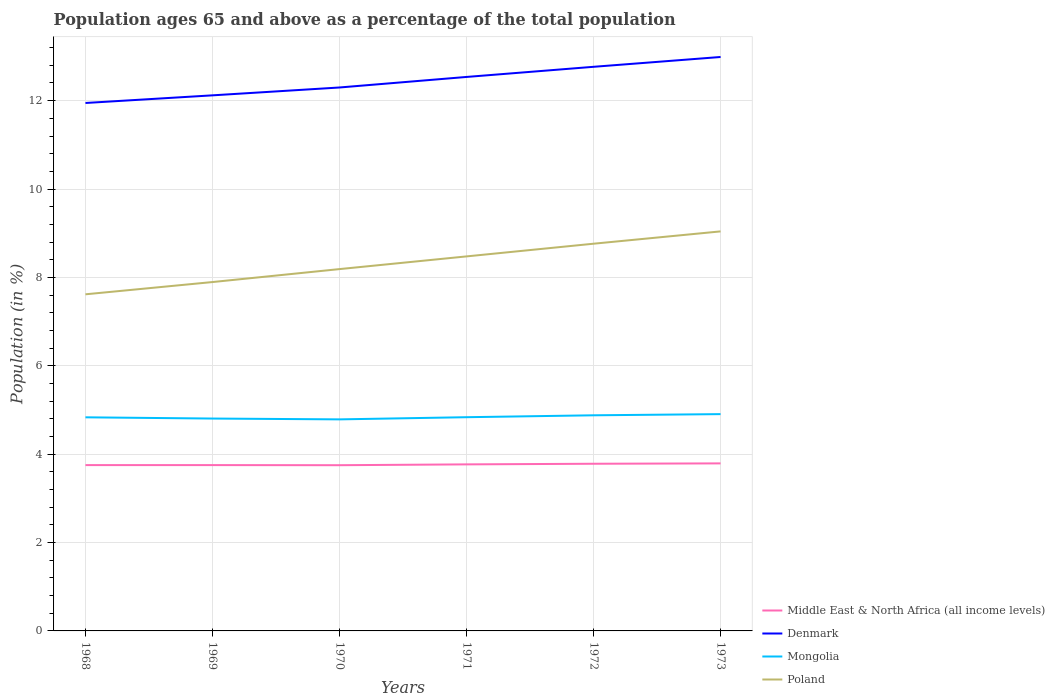How many different coloured lines are there?
Your answer should be very brief. 4. Does the line corresponding to Mongolia intersect with the line corresponding to Middle East & North Africa (all income levels)?
Offer a terse response. No. Across all years, what is the maximum percentage of the population ages 65 and above in Poland?
Your response must be concise. 7.62. In which year was the percentage of the population ages 65 and above in Denmark maximum?
Provide a succinct answer. 1968. What is the total percentage of the population ages 65 and above in Denmark in the graph?
Give a very brief answer. -0.17. What is the difference between the highest and the second highest percentage of the population ages 65 and above in Middle East & North Africa (all income levels)?
Your answer should be compact. 0.04. What is the difference between two consecutive major ticks on the Y-axis?
Ensure brevity in your answer.  2. Are the values on the major ticks of Y-axis written in scientific E-notation?
Provide a succinct answer. No. Does the graph contain any zero values?
Your answer should be very brief. No. How are the legend labels stacked?
Offer a terse response. Vertical. What is the title of the graph?
Your answer should be very brief. Population ages 65 and above as a percentage of the total population. What is the label or title of the Y-axis?
Give a very brief answer. Population (in %). What is the Population (in %) of Middle East & North Africa (all income levels) in 1968?
Your answer should be compact. 3.75. What is the Population (in %) in Denmark in 1968?
Provide a short and direct response. 11.95. What is the Population (in %) of Mongolia in 1968?
Make the answer very short. 4.83. What is the Population (in %) in Poland in 1968?
Keep it short and to the point. 7.62. What is the Population (in %) of Middle East & North Africa (all income levels) in 1969?
Give a very brief answer. 3.75. What is the Population (in %) of Denmark in 1969?
Keep it short and to the point. 12.12. What is the Population (in %) in Mongolia in 1969?
Provide a succinct answer. 4.81. What is the Population (in %) of Poland in 1969?
Ensure brevity in your answer.  7.9. What is the Population (in %) in Middle East & North Africa (all income levels) in 1970?
Make the answer very short. 3.75. What is the Population (in %) of Denmark in 1970?
Provide a succinct answer. 12.3. What is the Population (in %) of Mongolia in 1970?
Keep it short and to the point. 4.79. What is the Population (in %) of Poland in 1970?
Offer a terse response. 8.19. What is the Population (in %) of Middle East & North Africa (all income levels) in 1971?
Your answer should be very brief. 3.77. What is the Population (in %) in Denmark in 1971?
Your answer should be compact. 12.54. What is the Population (in %) in Mongolia in 1971?
Offer a very short reply. 4.84. What is the Population (in %) of Poland in 1971?
Your answer should be very brief. 8.48. What is the Population (in %) of Middle East & North Africa (all income levels) in 1972?
Make the answer very short. 3.78. What is the Population (in %) of Denmark in 1972?
Provide a short and direct response. 12.77. What is the Population (in %) of Mongolia in 1972?
Make the answer very short. 4.88. What is the Population (in %) in Poland in 1972?
Provide a succinct answer. 8.76. What is the Population (in %) of Middle East & North Africa (all income levels) in 1973?
Give a very brief answer. 3.79. What is the Population (in %) in Denmark in 1973?
Your answer should be very brief. 12.99. What is the Population (in %) in Mongolia in 1973?
Ensure brevity in your answer.  4.91. What is the Population (in %) in Poland in 1973?
Provide a succinct answer. 9.04. Across all years, what is the maximum Population (in %) of Middle East & North Africa (all income levels)?
Ensure brevity in your answer.  3.79. Across all years, what is the maximum Population (in %) in Denmark?
Keep it short and to the point. 12.99. Across all years, what is the maximum Population (in %) of Mongolia?
Provide a short and direct response. 4.91. Across all years, what is the maximum Population (in %) in Poland?
Make the answer very short. 9.04. Across all years, what is the minimum Population (in %) in Middle East & North Africa (all income levels)?
Ensure brevity in your answer.  3.75. Across all years, what is the minimum Population (in %) of Denmark?
Your answer should be very brief. 11.95. Across all years, what is the minimum Population (in %) in Mongolia?
Offer a terse response. 4.79. Across all years, what is the minimum Population (in %) of Poland?
Give a very brief answer. 7.62. What is the total Population (in %) of Middle East & North Africa (all income levels) in the graph?
Ensure brevity in your answer.  22.6. What is the total Population (in %) in Denmark in the graph?
Your answer should be compact. 74.66. What is the total Population (in %) in Mongolia in the graph?
Your answer should be compact. 29.05. What is the total Population (in %) of Poland in the graph?
Keep it short and to the point. 49.98. What is the difference between the Population (in %) of Middle East & North Africa (all income levels) in 1968 and that in 1969?
Your answer should be compact. 0. What is the difference between the Population (in %) of Denmark in 1968 and that in 1969?
Your answer should be compact. -0.17. What is the difference between the Population (in %) in Mongolia in 1968 and that in 1969?
Ensure brevity in your answer.  0.03. What is the difference between the Population (in %) of Poland in 1968 and that in 1969?
Offer a terse response. -0.28. What is the difference between the Population (in %) of Middle East & North Africa (all income levels) in 1968 and that in 1970?
Give a very brief answer. 0. What is the difference between the Population (in %) of Denmark in 1968 and that in 1970?
Keep it short and to the point. -0.35. What is the difference between the Population (in %) of Mongolia in 1968 and that in 1970?
Offer a very short reply. 0.05. What is the difference between the Population (in %) in Poland in 1968 and that in 1970?
Offer a terse response. -0.57. What is the difference between the Population (in %) in Middle East & North Africa (all income levels) in 1968 and that in 1971?
Your response must be concise. -0.02. What is the difference between the Population (in %) of Denmark in 1968 and that in 1971?
Ensure brevity in your answer.  -0.59. What is the difference between the Population (in %) of Mongolia in 1968 and that in 1971?
Make the answer very short. -0. What is the difference between the Population (in %) in Poland in 1968 and that in 1971?
Offer a very short reply. -0.86. What is the difference between the Population (in %) of Middle East & North Africa (all income levels) in 1968 and that in 1972?
Ensure brevity in your answer.  -0.03. What is the difference between the Population (in %) in Denmark in 1968 and that in 1972?
Offer a very short reply. -0.82. What is the difference between the Population (in %) of Mongolia in 1968 and that in 1972?
Ensure brevity in your answer.  -0.05. What is the difference between the Population (in %) of Poland in 1968 and that in 1972?
Offer a terse response. -1.14. What is the difference between the Population (in %) in Middle East & North Africa (all income levels) in 1968 and that in 1973?
Provide a succinct answer. -0.04. What is the difference between the Population (in %) in Denmark in 1968 and that in 1973?
Make the answer very short. -1.04. What is the difference between the Population (in %) in Mongolia in 1968 and that in 1973?
Your response must be concise. -0.07. What is the difference between the Population (in %) of Poland in 1968 and that in 1973?
Your answer should be very brief. -1.42. What is the difference between the Population (in %) in Middle East & North Africa (all income levels) in 1969 and that in 1970?
Ensure brevity in your answer.  0. What is the difference between the Population (in %) in Denmark in 1969 and that in 1970?
Provide a succinct answer. -0.18. What is the difference between the Population (in %) of Mongolia in 1969 and that in 1970?
Make the answer very short. 0.02. What is the difference between the Population (in %) of Poland in 1969 and that in 1970?
Make the answer very short. -0.29. What is the difference between the Population (in %) of Middle East & North Africa (all income levels) in 1969 and that in 1971?
Your answer should be compact. -0.02. What is the difference between the Population (in %) of Denmark in 1969 and that in 1971?
Your answer should be compact. -0.42. What is the difference between the Population (in %) in Mongolia in 1969 and that in 1971?
Your answer should be very brief. -0.03. What is the difference between the Population (in %) in Poland in 1969 and that in 1971?
Your response must be concise. -0.58. What is the difference between the Population (in %) in Middle East & North Africa (all income levels) in 1969 and that in 1972?
Your answer should be compact. -0.03. What is the difference between the Population (in %) of Denmark in 1969 and that in 1972?
Provide a short and direct response. -0.65. What is the difference between the Population (in %) in Mongolia in 1969 and that in 1972?
Make the answer very short. -0.07. What is the difference between the Population (in %) of Poland in 1969 and that in 1972?
Provide a short and direct response. -0.87. What is the difference between the Population (in %) in Middle East & North Africa (all income levels) in 1969 and that in 1973?
Provide a succinct answer. -0.04. What is the difference between the Population (in %) in Denmark in 1969 and that in 1973?
Make the answer very short. -0.87. What is the difference between the Population (in %) in Mongolia in 1969 and that in 1973?
Provide a succinct answer. -0.1. What is the difference between the Population (in %) in Poland in 1969 and that in 1973?
Your response must be concise. -1.15. What is the difference between the Population (in %) of Middle East & North Africa (all income levels) in 1970 and that in 1971?
Ensure brevity in your answer.  -0.02. What is the difference between the Population (in %) in Denmark in 1970 and that in 1971?
Provide a succinct answer. -0.24. What is the difference between the Population (in %) in Mongolia in 1970 and that in 1971?
Offer a terse response. -0.05. What is the difference between the Population (in %) of Poland in 1970 and that in 1971?
Ensure brevity in your answer.  -0.29. What is the difference between the Population (in %) of Middle East & North Africa (all income levels) in 1970 and that in 1972?
Your answer should be compact. -0.03. What is the difference between the Population (in %) of Denmark in 1970 and that in 1972?
Provide a succinct answer. -0.47. What is the difference between the Population (in %) in Mongolia in 1970 and that in 1972?
Make the answer very short. -0.09. What is the difference between the Population (in %) of Poland in 1970 and that in 1972?
Provide a short and direct response. -0.57. What is the difference between the Population (in %) of Middle East & North Africa (all income levels) in 1970 and that in 1973?
Provide a succinct answer. -0.04. What is the difference between the Population (in %) of Denmark in 1970 and that in 1973?
Your response must be concise. -0.69. What is the difference between the Population (in %) of Mongolia in 1970 and that in 1973?
Provide a short and direct response. -0.12. What is the difference between the Population (in %) in Poland in 1970 and that in 1973?
Offer a terse response. -0.85. What is the difference between the Population (in %) of Middle East & North Africa (all income levels) in 1971 and that in 1972?
Provide a succinct answer. -0.01. What is the difference between the Population (in %) of Denmark in 1971 and that in 1972?
Your answer should be compact. -0.23. What is the difference between the Population (in %) in Mongolia in 1971 and that in 1972?
Provide a succinct answer. -0.04. What is the difference between the Population (in %) of Poland in 1971 and that in 1972?
Offer a very short reply. -0.29. What is the difference between the Population (in %) in Middle East & North Africa (all income levels) in 1971 and that in 1973?
Your answer should be compact. -0.02. What is the difference between the Population (in %) of Denmark in 1971 and that in 1973?
Your answer should be compact. -0.45. What is the difference between the Population (in %) of Mongolia in 1971 and that in 1973?
Give a very brief answer. -0.07. What is the difference between the Population (in %) in Poland in 1971 and that in 1973?
Make the answer very short. -0.57. What is the difference between the Population (in %) of Middle East & North Africa (all income levels) in 1972 and that in 1973?
Provide a short and direct response. -0.01. What is the difference between the Population (in %) in Denmark in 1972 and that in 1973?
Give a very brief answer. -0.22. What is the difference between the Population (in %) of Mongolia in 1972 and that in 1973?
Ensure brevity in your answer.  -0.03. What is the difference between the Population (in %) of Poland in 1972 and that in 1973?
Give a very brief answer. -0.28. What is the difference between the Population (in %) in Middle East & North Africa (all income levels) in 1968 and the Population (in %) in Denmark in 1969?
Your response must be concise. -8.37. What is the difference between the Population (in %) of Middle East & North Africa (all income levels) in 1968 and the Population (in %) of Mongolia in 1969?
Provide a succinct answer. -1.05. What is the difference between the Population (in %) in Middle East & North Africa (all income levels) in 1968 and the Population (in %) in Poland in 1969?
Your answer should be very brief. -4.14. What is the difference between the Population (in %) of Denmark in 1968 and the Population (in %) of Mongolia in 1969?
Offer a very short reply. 7.14. What is the difference between the Population (in %) in Denmark in 1968 and the Population (in %) in Poland in 1969?
Offer a terse response. 4.05. What is the difference between the Population (in %) in Mongolia in 1968 and the Population (in %) in Poland in 1969?
Provide a short and direct response. -3.06. What is the difference between the Population (in %) in Middle East & North Africa (all income levels) in 1968 and the Population (in %) in Denmark in 1970?
Provide a short and direct response. -8.55. What is the difference between the Population (in %) in Middle East & North Africa (all income levels) in 1968 and the Population (in %) in Mongolia in 1970?
Your response must be concise. -1.03. What is the difference between the Population (in %) of Middle East & North Africa (all income levels) in 1968 and the Population (in %) of Poland in 1970?
Ensure brevity in your answer.  -4.44. What is the difference between the Population (in %) of Denmark in 1968 and the Population (in %) of Mongolia in 1970?
Provide a short and direct response. 7.16. What is the difference between the Population (in %) in Denmark in 1968 and the Population (in %) in Poland in 1970?
Provide a succinct answer. 3.76. What is the difference between the Population (in %) of Mongolia in 1968 and the Population (in %) of Poland in 1970?
Offer a terse response. -3.35. What is the difference between the Population (in %) of Middle East & North Africa (all income levels) in 1968 and the Population (in %) of Denmark in 1971?
Give a very brief answer. -8.78. What is the difference between the Population (in %) in Middle East & North Africa (all income levels) in 1968 and the Population (in %) in Mongolia in 1971?
Your answer should be very brief. -1.08. What is the difference between the Population (in %) of Middle East & North Africa (all income levels) in 1968 and the Population (in %) of Poland in 1971?
Provide a succinct answer. -4.72. What is the difference between the Population (in %) of Denmark in 1968 and the Population (in %) of Mongolia in 1971?
Your answer should be compact. 7.11. What is the difference between the Population (in %) in Denmark in 1968 and the Population (in %) in Poland in 1971?
Ensure brevity in your answer.  3.47. What is the difference between the Population (in %) in Mongolia in 1968 and the Population (in %) in Poland in 1971?
Keep it short and to the point. -3.64. What is the difference between the Population (in %) of Middle East & North Africa (all income levels) in 1968 and the Population (in %) of Denmark in 1972?
Provide a succinct answer. -9.01. What is the difference between the Population (in %) in Middle East & North Africa (all income levels) in 1968 and the Population (in %) in Mongolia in 1972?
Ensure brevity in your answer.  -1.13. What is the difference between the Population (in %) in Middle East & North Africa (all income levels) in 1968 and the Population (in %) in Poland in 1972?
Keep it short and to the point. -5.01. What is the difference between the Population (in %) of Denmark in 1968 and the Population (in %) of Mongolia in 1972?
Provide a short and direct response. 7.07. What is the difference between the Population (in %) of Denmark in 1968 and the Population (in %) of Poland in 1972?
Your answer should be compact. 3.18. What is the difference between the Population (in %) of Mongolia in 1968 and the Population (in %) of Poland in 1972?
Your answer should be compact. -3.93. What is the difference between the Population (in %) of Middle East & North Africa (all income levels) in 1968 and the Population (in %) of Denmark in 1973?
Offer a very short reply. -9.24. What is the difference between the Population (in %) of Middle East & North Africa (all income levels) in 1968 and the Population (in %) of Mongolia in 1973?
Your response must be concise. -1.15. What is the difference between the Population (in %) of Middle East & North Africa (all income levels) in 1968 and the Population (in %) of Poland in 1973?
Keep it short and to the point. -5.29. What is the difference between the Population (in %) of Denmark in 1968 and the Population (in %) of Mongolia in 1973?
Your answer should be compact. 7.04. What is the difference between the Population (in %) of Denmark in 1968 and the Population (in %) of Poland in 1973?
Your answer should be compact. 2.91. What is the difference between the Population (in %) of Mongolia in 1968 and the Population (in %) of Poland in 1973?
Offer a terse response. -4.21. What is the difference between the Population (in %) in Middle East & North Africa (all income levels) in 1969 and the Population (in %) in Denmark in 1970?
Offer a very short reply. -8.55. What is the difference between the Population (in %) in Middle East & North Africa (all income levels) in 1969 and the Population (in %) in Mongolia in 1970?
Provide a short and direct response. -1.03. What is the difference between the Population (in %) in Middle East & North Africa (all income levels) in 1969 and the Population (in %) in Poland in 1970?
Offer a very short reply. -4.44. What is the difference between the Population (in %) in Denmark in 1969 and the Population (in %) in Mongolia in 1970?
Your answer should be compact. 7.33. What is the difference between the Population (in %) in Denmark in 1969 and the Population (in %) in Poland in 1970?
Give a very brief answer. 3.93. What is the difference between the Population (in %) of Mongolia in 1969 and the Population (in %) of Poland in 1970?
Keep it short and to the point. -3.38. What is the difference between the Population (in %) of Middle East & North Africa (all income levels) in 1969 and the Population (in %) of Denmark in 1971?
Provide a succinct answer. -8.78. What is the difference between the Population (in %) in Middle East & North Africa (all income levels) in 1969 and the Population (in %) in Mongolia in 1971?
Offer a terse response. -1.08. What is the difference between the Population (in %) in Middle East & North Africa (all income levels) in 1969 and the Population (in %) in Poland in 1971?
Make the answer very short. -4.72. What is the difference between the Population (in %) in Denmark in 1969 and the Population (in %) in Mongolia in 1971?
Keep it short and to the point. 7.28. What is the difference between the Population (in %) of Denmark in 1969 and the Population (in %) of Poland in 1971?
Your answer should be compact. 3.64. What is the difference between the Population (in %) of Mongolia in 1969 and the Population (in %) of Poland in 1971?
Give a very brief answer. -3.67. What is the difference between the Population (in %) of Middle East & North Africa (all income levels) in 1969 and the Population (in %) of Denmark in 1972?
Give a very brief answer. -9.01. What is the difference between the Population (in %) of Middle East & North Africa (all income levels) in 1969 and the Population (in %) of Mongolia in 1972?
Offer a terse response. -1.13. What is the difference between the Population (in %) of Middle East & North Africa (all income levels) in 1969 and the Population (in %) of Poland in 1972?
Keep it short and to the point. -5.01. What is the difference between the Population (in %) of Denmark in 1969 and the Population (in %) of Mongolia in 1972?
Keep it short and to the point. 7.24. What is the difference between the Population (in %) of Denmark in 1969 and the Population (in %) of Poland in 1972?
Provide a short and direct response. 3.36. What is the difference between the Population (in %) in Mongolia in 1969 and the Population (in %) in Poland in 1972?
Your response must be concise. -3.96. What is the difference between the Population (in %) in Middle East & North Africa (all income levels) in 1969 and the Population (in %) in Denmark in 1973?
Provide a short and direct response. -9.24. What is the difference between the Population (in %) of Middle East & North Africa (all income levels) in 1969 and the Population (in %) of Mongolia in 1973?
Your response must be concise. -1.15. What is the difference between the Population (in %) in Middle East & North Africa (all income levels) in 1969 and the Population (in %) in Poland in 1973?
Provide a short and direct response. -5.29. What is the difference between the Population (in %) of Denmark in 1969 and the Population (in %) of Mongolia in 1973?
Your answer should be very brief. 7.21. What is the difference between the Population (in %) in Denmark in 1969 and the Population (in %) in Poland in 1973?
Give a very brief answer. 3.08. What is the difference between the Population (in %) in Mongolia in 1969 and the Population (in %) in Poland in 1973?
Your answer should be very brief. -4.24. What is the difference between the Population (in %) in Middle East & North Africa (all income levels) in 1970 and the Population (in %) in Denmark in 1971?
Make the answer very short. -8.79. What is the difference between the Population (in %) in Middle East & North Africa (all income levels) in 1970 and the Population (in %) in Mongolia in 1971?
Your answer should be very brief. -1.09. What is the difference between the Population (in %) of Middle East & North Africa (all income levels) in 1970 and the Population (in %) of Poland in 1971?
Keep it short and to the point. -4.73. What is the difference between the Population (in %) of Denmark in 1970 and the Population (in %) of Mongolia in 1971?
Provide a short and direct response. 7.46. What is the difference between the Population (in %) of Denmark in 1970 and the Population (in %) of Poland in 1971?
Your answer should be compact. 3.82. What is the difference between the Population (in %) of Mongolia in 1970 and the Population (in %) of Poland in 1971?
Your answer should be very brief. -3.69. What is the difference between the Population (in %) in Middle East & North Africa (all income levels) in 1970 and the Population (in %) in Denmark in 1972?
Your response must be concise. -9.02. What is the difference between the Population (in %) in Middle East & North Africa (all income levels) in 1970 and the Population (in %) in Mongolia in 1972?
Keep it short and to the point. -1.13. What is the difference between the Population (in %) of Middle East & North Africa (all income levels) in 1970 and the Population (in %) of Poland in 1972?
Keep it short and to the point. -5.01. What is the difference between the Population (in %) of Denmark in 1970 and the Population (in %) of Mongolia in 1972?
Your answer should be compact. 7.42. What is the difference between the Population (in %) of Denmark in 1970 and the Population (in %) of Poland in 1972?
Your answer should be very brief. 3.54. What is the difference between the Population (in %) in Mongolia in 1970 and the Population (in %) in Poland in 1972?
Give a very brief answer. -3.98. What is the difference between the Population (in %) in Middle East & North Africa (all income levels) in 1970 and the Population (in %) in Denmark in 1973?
Make the answer very short. -9.24. What is the difference between the Population (in %) of Middle East & North Africa (all income levels) in 1970 and the Population (in %) of Mongolia in 1973?
Offer a very short reply. -1.16. What is the difference between the Population (in %) of Middle East & North Africa (all income levels) in 1970 and the Population (in %) of Poland in 1973?
Offer a very short reply. -5.29. What is the difference between the Population (in %) of Denmark in 1970 and the Population (in %) of Mongolia in 1973?
Provide a succinct answer. 7.39. What is the difference between the Population (in %) of Denmark in 1970 and the Population (in %) of Poland in 1973?
Your answer should be compact. 3.26. What is the difference between the Population (in %) in Mongolia in 1970 and the Population (in %) in Poland in 1973?
Keep it short and to the point. -4.25. What is the difference between the Population (in %) in Middle East & North Africa (all income levels) in 1971 and the Population (in %) in Denmark in 1972?
Give a very brief answer. -9. What is the difference between the Population (in %) of Middle East & North Africa (all income levels) in 1971 and the Population (in %) of Mongolia in 1972?
Give a very brief answer. -1.11. What is the difference between the Population (in %) of Middle East & North Africa (all income levels) in 1971 and the Population (in %) of Poland in 1972?
Provide a succinct answer. -4.99. What is the difference between the Population (in %) in Denmark in 1971 and the Population (in %) in Mongolia in 1972?
Provide a short and direct response. 7.66. What is the difference between the Population (in %) in Denmark in 1971 and the Population (in %) in Poland in 1972?
Your answer should be compact. 3.77. What is the difference between the Population (in %) in Mongolia in 1971 and the Population (in %) in Poland in 1972?
Ensure brevity in your answer.  -3.93. What is the difference between the Population (in %) in Middle East & North Africa (all income levels) in 1971 and the Population (in %) in Denmark in 1973?
Provide a short and direct response. -9.22. What is the difference between the Population (in %) of Middle East & North Africa (all income levels) in 1971 and the Population (in %) of Mongolia in 1973?
Keep it short and to the point. -1.14. What is the difference between the Population (in %) of Middle East & North Africa (all income levels) in 1971 and the Population (in %) of Poland in 1973?
Offer a terse response. -5.27. What is the difference between the Population (in %) of Denmark in 1971 and the Population (in %) of Mongolia in 1973?
Make the answer very short. 7.63. What is the difference between the Population (in %) in Denmark in 1971 and the Population (in %) in Poland in 1973?
Offer a very short reply. 3.5. What is the difference between the Population (in %) in Mongolia in 1971 and the Population (in %) in Poland in 1973?
Provide a succinct answer. -4.21. What is the difference between the Population (in %) of Middle East & North Africa (all income levels) in 1972 and the Population (in %) of Denmark in 1973?
Ensure brevity in your answer.  -9.21. What is the difference between the Population (in %) in Middle East & North Africa (all income levels) in 1972 and the Population (in %) in Mongolia in 1973?
Make the answer very short. -1.12. What is the difference between the Population (in %) of Middle East & North Africa (all income levels) in 1972 and the Population (in %) of Poland in 1973?
Offer a very short reply. -5.26. What is the difference between the Population (in %) of Denmark in 1972 and the Population (in %) of Mongolia in 1973?
Give a very brief answer. 7.86. What is the difference between the Population (in %) in Denmark in 1972 and the Population (in %) in Poland in 1973?
Offer a terse response. 3.72. What is the difference between the Population (in %) in Mongolia in 1972 and the Population (in %) in Poland in 1973?
Provide a short and direct response. -4.16. What is the average Population (in %) in Middle East & North Africa (all income levels) per year?
Your answer should be very brief. 3.77. What is the average Population (in %) of Denmark per year?
Provide a short and direct response. 12.44. What is the average Population (in %) of Mongolia per year?
Ensure brevity in your answer.  4.84. What is the average Population (in %) in Poland per year?
Your answer should be very brief. 8.33. In the year 1968, what is the difference between the Population (in %) of Middle East & North Africa (all income levels) and Population (in %) of Denmark?
Give a very brief answer. -8.19. In the year 1968, what is the difference between the Population (in %) of Middle East & North Africa (all income levels) and Population (in %) of Mongolia?
Provide a succinct answer. -1.08. In the year 1968, what is the difference between the Population (in %) of Middle East & North Africa (all income levels) and Population (in %) of Poland?
Provide a succinct answer. -3.86. In the year 1968, what is the difference between the Population (in %) of Denmark and Population (in %) of Mongolia?
Make the answer very short. 7.11. In the year 1968, what is the difference between the Population (in %) of Denmark and Population (in %) of Poland?
Provide a succinct answer. 4.33. In the year 1968, what is the difference between the Population (in %) in Mongolia and Population (in %) in Poland?
Your answer should be compact. -2.78. In the year 1969, what is the difference between the Population (in %) of Middle East & North Africa (all income levels) and Population (in %) of Denmark?
Offer a terse response. -8.37. In the year 1969, what is the difference between the Population (in %) of Middle East & North Africa (all income levels) and Population (in %) of Mongolia?
Offer a very short reply. -1.05. In the year 1969, what is the difference between the Population (in %) of Middle East & North Africa (all income levels) and Population (in %) of Poland?
Offer a very short reply. -4.14. In the year 1969, what is the difference between the Population (in %) of Denmark and Population (in %) of Mongolia?
Make the answer very short. 7.31. In the year 1969, what is the difference between the Population (in %) in Denmark and Population (in %) in Poland?
Your answer should be compact. 4.23. In the year 1969, what is the difference between the Population (in %) in Mongolia and Population (in %) in Poland?
Provide a short and direct response. -3.09. In the year 1970, what is the difference between the Population (in %) of Middle East & North Africa (all income levels) and Population (in %) of Denmark?
Your response must be concise. -8.55. In the year 1970, what is the difference between the Population (in %) of Middle East & North Africa (all income levels) and Population (in %) of Mongolia?
Ensure brevity in your answer.  -1.04. In the year 1970, what is the difference between the Population (in %) of Middle East & North Africa (all income levels) and Population (in %) of Poland?
Give a very brief answer. -4.44. In the year 1970, what is the difference between the Population (in %) in Denmark and Population (in %) in Mongolia?
Offer a terse response. 7.51. In the year 1970, what is the difference between the Population (in %) of Denmark and Population (in %) of Poland?
Make the answer very short. 4.11. In the year 1970, what is the difference between the Population (in %) in Mongolia and Population (in %) in Poland?
Provide a succinct answer. -3.4. In the year 1971, what is the difference between the Population (in %) of Middle East & North Africa (all income levels) and Population (in %) of Denmark?
Your response must be concise. -8.77. In the year 1971, what is the difference between the Population (in %) of Middle East & North Africa (all income levels) and Population (in %) of Mongolia?
Your answer should be very brief. -1.07. In the year 1971, what is the difference between the Population (in %) in Middle East & North Africa (all income levels) and Population (in %) in Poland?
Provide a short and direct response. -4.71. In the year 1971, what is the difference between the Population (in %) of Denmark and Population (in %) of Mongolia?
Your answer should be compact. 7.7. In the year 1971, what is the difference between the Population (in %) in Denmark and Population (in %) in Poland?
Your response must be concise. 4.06. In the year 1971, what is the difference between the Population (in %) of Mongolia and Population (in %) of Poland?
Give a very brief answer. -3.64. In the year 1972, what is the difference between the Population (in %) in Middle East & North Africa (all income levels) and Population (in %) in Denmark?
Your response must be concise. -8.98. In the year 1972, what is the difference between the Population (in %) in Middle East & North Africa (all income levels) and Population (in %) in Mongolia?
Provide a short and direct response. -1.1. In the year 1972, what is the difference between the Population (in %) in Middle East & North Africa (all income levels) and Population (in %) in Poland?
Your response must be concise. -4.98. In the year 1972, what is the difference between the Population (in %) in Denmark and Population (in %) in Mongolia?
Offer a very short reply. 7.89. In the year 1972, what is the difference between the Population (in %) of Denmark and Population (in %) of Poland?
Your answer should be compact. 4. In the year 1972, what is the difference between the Population (in %) of Mongolia and Population (in %) of Poland?
Offer a very short reply. -3.88. In the year 1973, what is the difference between the Population (in %) of Middle East & North Africa (all income levels) and Population (in %) of Denmark?
Provide a short and direct response. -9.2. In the year 1973, what is the difference between the Population (in %) in Middle East & North Africa (all income levels) and Population (in %) in Mongolia?
Ensure brevity in your answer.  -1.11. In the year 1973, what is the difference between the Population (in %) of Middle East & North Africa (all income levels) and Population (in %) of Poland?
Offer a very short reply. -5.25. In the year 1973, what is the difference between the Population (in %) of Denmark and Population (in %) of Mongolia?
Offer a very short reply. 8.08. In the year 1973, what is the difference between the Population (in %) in Denmark and Population (in %) in Poland?
Offer a terse response. 3.95. In the year 1973, what is the difference between the Population (in %) of Mongolia and Population (in %) of Poland?
Provide a succinct answer. -4.14. What is the ratio of the Population (in %) in Denmark in 1968 to that in 1969?
Give a very brief answer. 0.99. What is the ratio of the Population (in %) of Mongolia in 1968 to that in 1969?
Your answer should be very brief. 1.01. What is the ratio of the Population (in %) in Poland in 1968 to that in 1969?
Ensure brevity in your answer.  0.96. What is the ratio of the Population (in %) of Denmark in 1968 to that in 1970?
Make the answer very short. 0.97. What is the ratio of the Population (in %) in Mongolia in 1968 to that in 1970?
Provide a short and direct response. 1.01. What is the ratio of the Population (in %) in Poland in 1968 to that in 1970?
Your response must be concise. 0.93. What is the ratio of the Population (in %) in Denmark in 1968 to that in 1971?
Make the answer very short. 0.95. What is the ratio of the Population (in %) in Mongolia in 1968 to that in 1971?
Your response must be concise. 1. What is the ratio of the Population (in %) in Poland in 1968 to that in 1971?
Your answer should be very brief. 0.9. What is the ratio of the Population (in %) of Denmark in 1968 to that in 1972?
Offer a very short reply. 0.94. What is the ratio of the Population (in %) of Poland in 1968 to that in 1972?
Ensure brevity in your answer.  0.87. What is the ratio of the Population (in %) of Denmark in 1968 to that in 1973?
Make the answer very short. 0.92. What is the ratio of the Population (in %) in Poland in 1968 to that in 1973?
Give a very brief answer. 0.84. What is the ratio of the Population (in %) in Denmark in 1969 to that in 1970?
Offer a very short reply. 0.99. What is the ratio of the Population (in %) in Mongolia in 1969 to that in 1970?
Make the answer very short. 1. What is the ratio of the Population (in %) in Poland in 1969 to that in 1970?
Make the answer very short. 0.96. What is the ratio of the Population (in %) of Denmark in 1969 to that in 1971?
Offer a very short reply. 0.97. What is the ratio of the Population (in %) in Mongolia in 1969 to that in 1971?
Offer a very short reply. 0.99. What is the ratio of the Population (in %) in Poland in 1969 to that in 1971?
Offer a very short reply. 0.93. What is the ratio of the Population (in %) in Middle East & North Africa (all income levels) in 1969 to that in 1972?
Your answer should be very brief. 0.99. What is the ratio of the Population (in %) in Denmark in 1969 to that in 1972?
Offer a very short reply. 0.95. What is the ratio of the Population (in %) in Mongolia in 1969 to that in 1972?
Offer a very short reply. 0.98. What is the ratio of the Population (in %) of Poland in 1969 to that in 1972?
Offer a very short reply. 0.9. What is the ratio of the Population (in %) in Middle East & North Africa (all income levels) in 1969 to that in 1973?
Provide a short and direct response. 0.99. What is the ratio of the Population (in %) in Denmark in 1969 to that in 1973?
Give a very brief answer. 0.93. What is the ratio of the Population (in %) in Mongolia in 1969 to that in 1973?
Make the answer very short. 0.98. What is the ratio of the Population (in %) of Poland in 1969 to that in 1973?
Offer a terse response. 0.87. What is the ratio of the Population (in %) in Denmark in 1970 to that in 1971?
Provide a short and direct response. 0.98. What is the ratio of the Population (in %) of Poland in 1970 to that in 1971?
Offer a terse response. 0.97. What is the ratio of the Population (in %) in Middle East & North Africa (all income levels) in 1970 to that in 1972?
Offer a terse response. 0.99. What is the ratio of the Population (in %) in Denmark in 1970 to that in 1972?
Ensure brevity in your answer.  0.96. What is the ratio of the Population (in %) of Mongolia in 1970 to that in 1972?
Offer a very short reply. 0.98. What is the ratio of the Population (in %) of Poland in 1970 to that in 1972?
Make the answer very short. 0.93. What is the ratio of the Population (in %) in Denmark in 1970 to that in 1973?
Your response must be concise. 0.95. What is the ratio of the Population (in %) in Mongolia in 1970 to that in 1973?
Your answer should be compact. 0.98. What is the ratio of the Population (in %) of Poland in 1970 to that in 1973?
Provide a short and direct response. 0.91. What is the ratio of the Population (in %) in Middle East & North Africa (all income levels) in 1971 to that in 1972?
Provide a succinct answer. 1. What is the ratio of the Population (in %) of Mongolia in 1971 to that in 1972?
Your response must be concise. 0.99. What is the ratio of the Population (in %) of Poland in 1971 to that in 1972?
Offer a very short reply. 0.97. What is the ratio of the Population (in %) of Denmark in 1971 to that in 1973?
Your response must be concise. 0.97. What is the ratio of the Population (in %) in Mongolia in 1971 to that in 1973?
Provide a short and direct response. 0.99. What is the ratio of the Population (in %) in Poland in 1971 to that in 1973?
Offer a very short reply. 0.94. What is the ratio of the Population (in %) of Middle East & North Africa (all income levels) in 1972 to that in 1973?
Your answer should be compact. 1. What is the ratio of the Population (in %) in Denmark in 1972 to that in 1973?
Ensure brevity in your answer.  0.98. What is the ratio of the Population (in %) of Mongolia in 1972 to that in 1973?
Your response must be concise. 0.99. What is the ratio of the Population (in %) of Poland in 1972 to that in 1973?
Give a very brief answer. 0.97. What is the difference between the highest and the second highest Population (in %) of Middle East & North Africa (all income levels)?
Your answer should be compact. 0.01. What is the difference between the highest and the second highest Population (in %) of Denmark?
Offer a very short reply. 0.22. What is the difference between the highest and the second highest Population (in %) of Mongolia?
Give a very brief answer. 0.03. What is the difference between the highest and the second highest Population (in %) in Poland?
Your answer should be very brief. 0.28. What is the difference between the highest and the lowest Population (in %) of Middle East & North Africa (all income levels)?
Your answer should be very brief. 0.04. What is the difference between the highest and the lowest Population (in %) of Denmark?
Your answer should be compact. 1.04. What is the difference between the highest and the lowest Population (in %) in Mongolia?
Your response must be concise. 0.12. What is the difference between the highest and the lowest Population (in %) in Poland?
Ensure brevity in your answer.  1.42. 